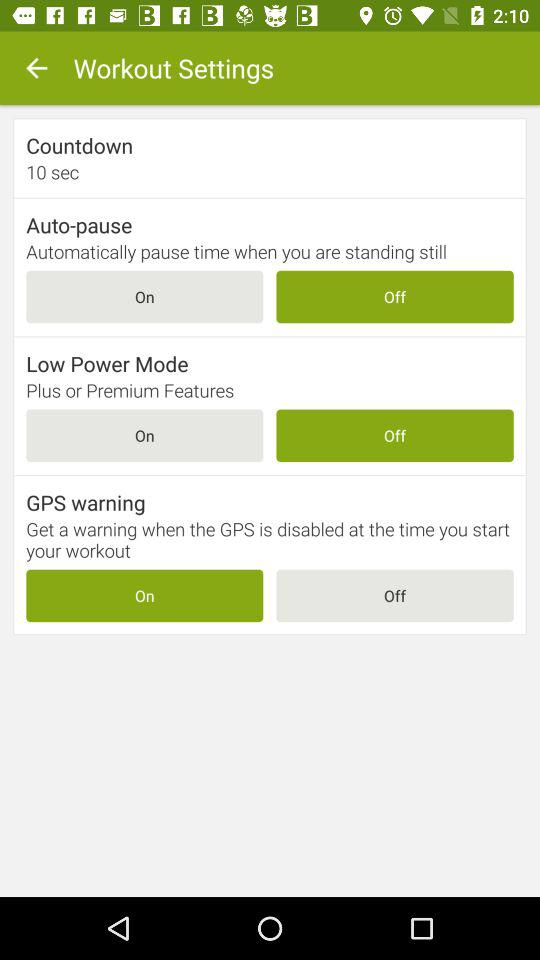What is the status of "Low Power Mode"? The status is off. 